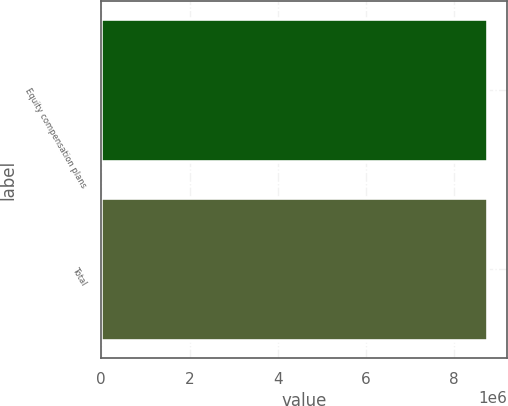Convert chart. <chart><loc_0><loc_0><loc_500><loc_500><bar_chart><fcel>Equity compensation plans<fcel>Total<nl><fcel>8.7612e+06<fcel>8.7612e+06<nl></chart> 